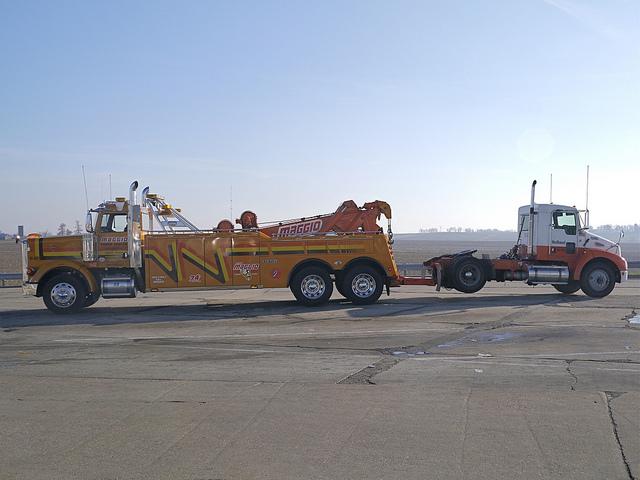Is this photo taken in the woods?
Be succinct. No. Where is the truck?
Write a very short answer. In parking lot. How many tires on are the vehicle doing the hauling?
Give a very brief answer. 6. What color is the truck?
Be succinct. Orange. What is the truck towing?
Concise answer only. Truck. Overcast or sunny?
Be succinct. Sunny. Is it cloudy?
Keep it brief. No. Are the trucks competing?
Write a very short answer. No. What is the main color of the vehicle?
Write a very short answer. Yellow. Is the scene shady?
Answer briefly. No. Which vehicle is doing the hauling?
Write a very short answer. Yellow. 